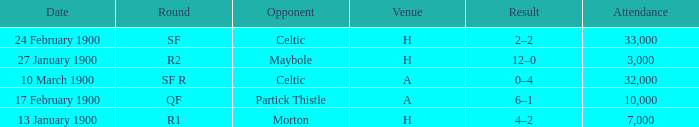What round did the celtic played away on 24 february 1900? SF. 